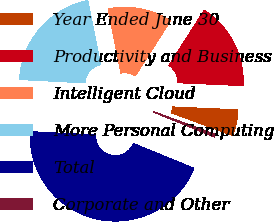Convert chart. <chart><loc_0><loc_0><loc_500><loc_500><pie_chart><fcel>Year Ended June 30<fcel>Productivity and Business<fcel>Intelligent Cloud<fcel>More Personal Computing<fcel>Total<fcel>Corporate and Other<nl><fcel>4.95%<fcel>16.63%<fcel>12.22%<fcel>21.03%<fcel>44.63%<fcel>0.54%<nl></chart> 